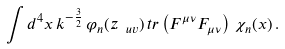Convert formula to latex. <formula><loc_0><loc_0><loc_500><loc_500>\int d ^ { 4 } x \, k ^ { - \frac { 3 } { 2 } } \, \varphi _ { n } ( z _ { \ u v } ) \, t r \left ( F ^ { \mu \nu } F _ { \mu \nu } \right ) \, \chi _ { n } ( x ) \, .</formula> 